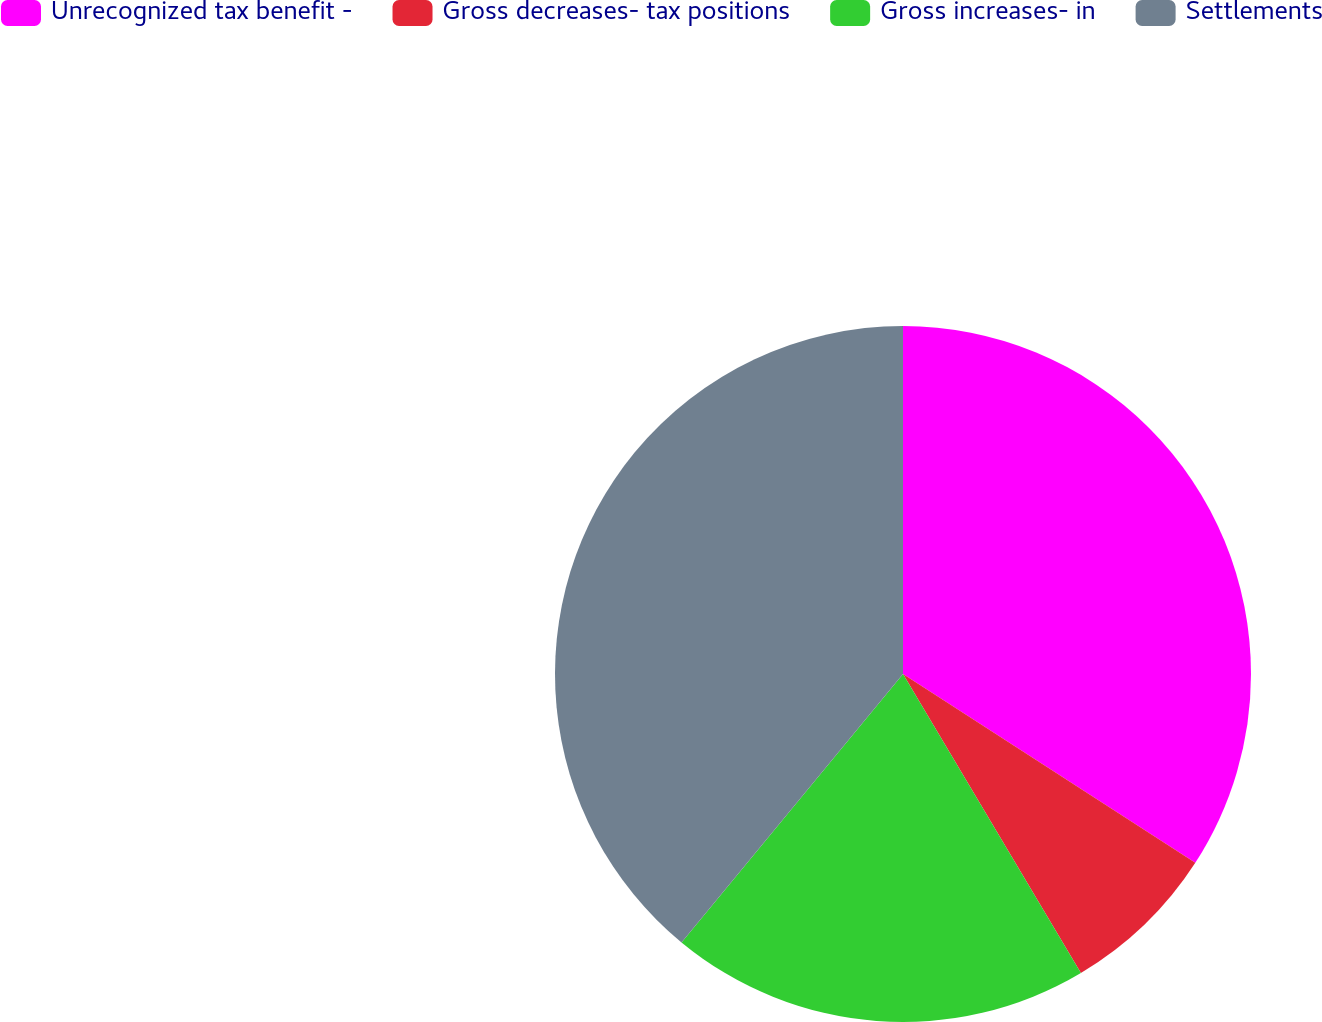Convert chart to OTSL. <chart><loc_0><loc_0><loc_500><loc_500><pie_chart><fcel>Unrecognized tax benefit -<fcel>Gross decreases- tax positions<fcel>Gross increases- in<fcel>Settlements<nl><fcel>34.13%<fcel>7.33%<fcel>19.52%<fcel>39.02%<nl></chart> 